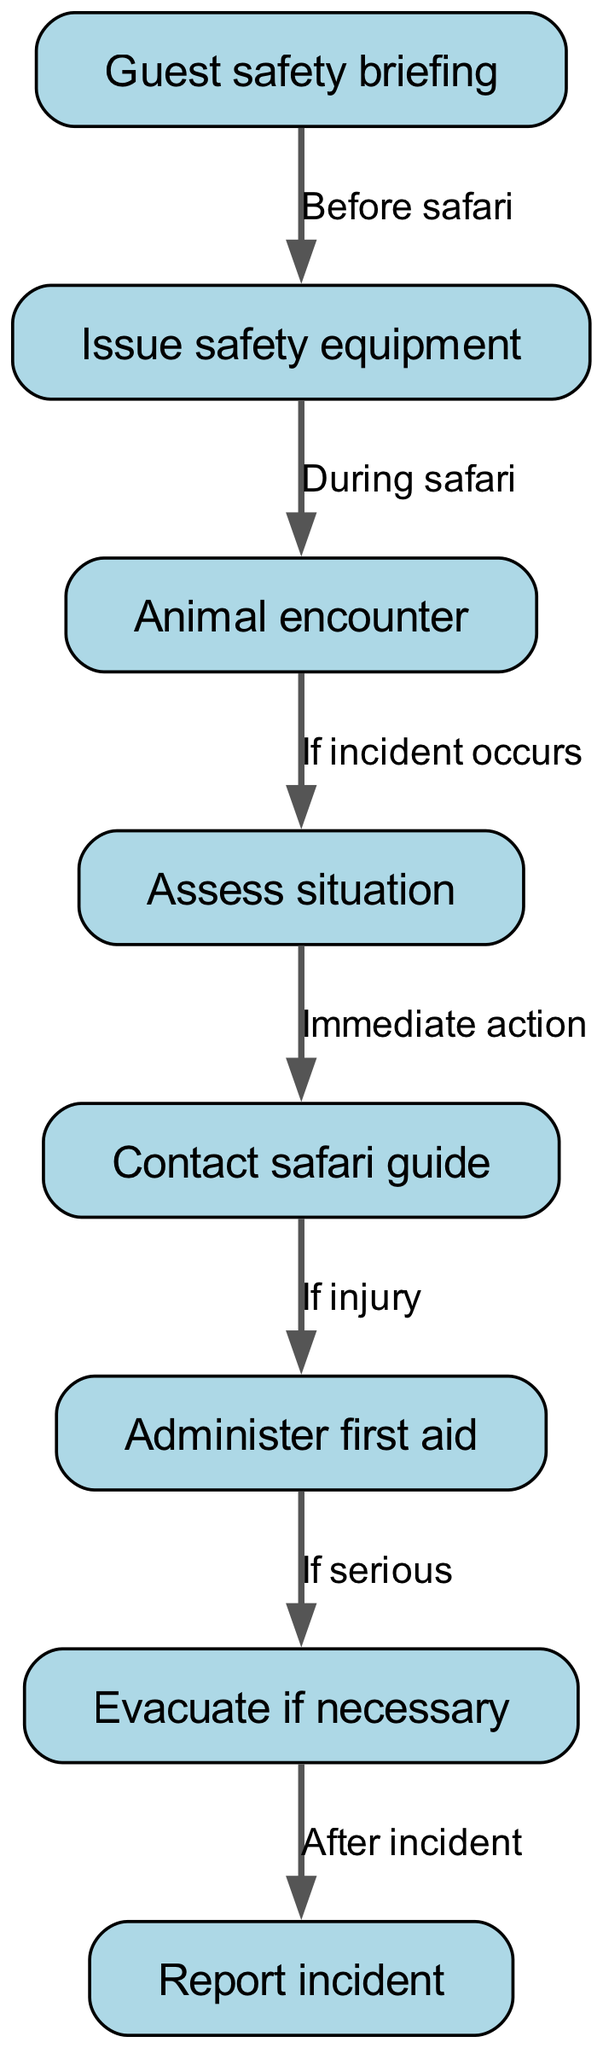What is the first step in the pathway? The first step in the pathway is "Guest safety briefing," as indicated by the node labeled with this text at the beginning of the flow.
Answer: Guest safety briefing How many nodes are in the diagram? The diagram contains 8 nodes, which represent different elements in the wildlife encounter safety protocol.
Answer: 8 What is the action taken after issuing safety equipment? The action taken after issuing safety equipment is "Animal encounter," which follows the edge labeled "During safari."
Answer: Animal encounter What happens if an injury occurs during an animal encounter? If an injury occurs, the next action is to "Administer first aid," as indicated by the pathway connecting from "Contact safari guide" to "Administer first aid."
Answer: Administer first aid How do you report an incident? An incident is reported after assessing the situation and evacuating if necessary, indicating that reporting occurs in the final step of the pathway after taking required actions.
Answer: Report incident What is the relationship between assessing the situation and contacting the safari guide? The relationship is that assessing the situation is the immediate action taken after an animal encounter; this leads to contacting the safari guide for further assistance.
Answer: Immediate action What is required before the safari starts? Before the safari starts, a "Guest safety briefing" is required to prepare guests for their wildlife experience and ensure their safety.
Answer: Guest safety briefing What should be done if serious injury occurs? If a serious injury occurs, "Evacuate if necessary" is the next step to ensure the safety of the injured person by seeking further medical assistance.
Answer: Evacuate if necessary 